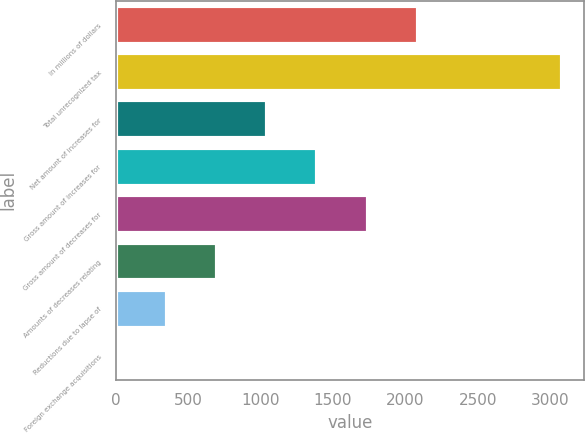Convert chart. <chart><loc_0><loc_0><loc_500><loc_500><bar_chart><fcel>In millions of dollars<fcel>Total unrecognized tax<fcel>Net amount of increases for<fcel>Gross amount of increases for<fcel>Gross amount of decreases for<fcel>Amounts of decreases relating<fcel>Reductions due to lapse of<fcel>Foreign exchange acquisitions<nl><fcel>2084.8<fcel>3079<fcel>1047.4<fcel>1393.2<fcel>1739<fcel>701.6<fcel>355.8<fcel>10<nl></chart> 